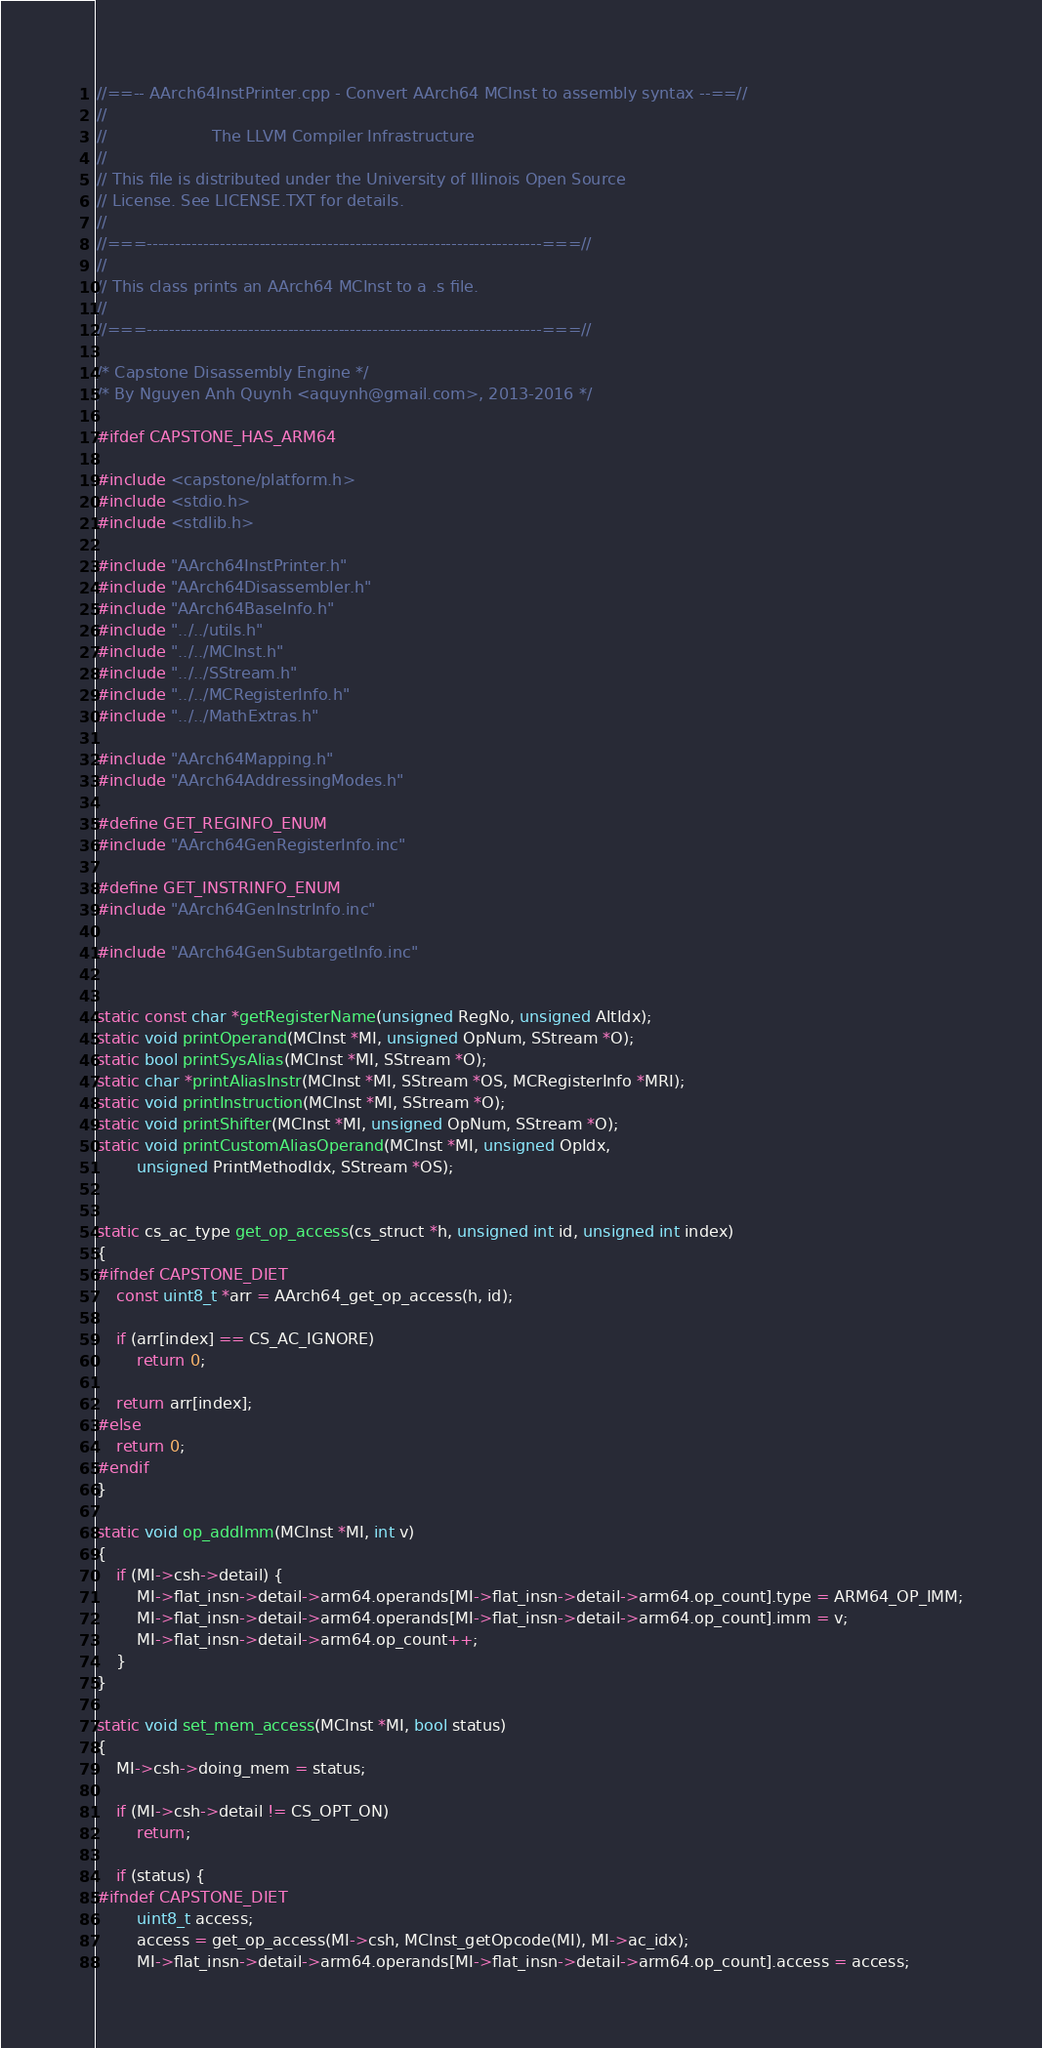Convert code to text. <code><loc_0><loc_0><loc_500><loc_500><_C_>//==-- AArch64InstPrinter.cpp - Convert AArch64 MCInst to assembly syntax --==//
//
//                     The LLVM Compiler Infrastructure
//
// This file is distributed under the University of Illinois Open Source
// License. See LICENSE.TXT for details.
//
//===----------------------------------------------------------------------===//
//
// This class prints an AArch64 MCInst to a .s file.
//
//===----------------------------------------------------------------------===//

/* Capstone Disassembly Engine */
/* By Nguyen Anh Quynh <aquynh@gmail.com>, 2013-2016 */

#ifdef CAPSTONE_HAS_ARM64

#include <capstone/platform.h>
#include <stdio.h>
#include <stdlib.h>

#include "AArch64InstPrinter.h"
#include "AArch64Disassembler.h"
#include "AArch64BaseInfo.h"
#include "../../utils.h"
#include "../../MCInst.h"
#include "../../SStream.h"
#include "../../MCRegisterInfo.h"
#include "../../MathExtras.h"

#include "AArch64Mapping.h"
#include "AArch64AddressingModes.h"

#define GET_REGINFO_ENUM
#include "AArch64GenRegisterInfo.inc"

#define GET_INSTRINFO_ENUM
#include "AArch64GenInstrInfo.inc"

#include "AArch64GenSubtargetInfo.inc"


static const char *getRegisterName(unsigned RegNo, unsigned AltIdx);
static void printOperand(MCInst *MI, unsigned OpNum, SStream *O);
static bool printSysAlias(MCInst *MI, SStream *O);
static char *printAliasInstr(MCInst *MI, SStream *OS, MCRegisterInfo *MRI);
static void printInstruction(MCInst *MI, SStream *O);
static void printShifter(MCInst *MI, unsigned OpNum, SStream *O);
static void printCustomAliasOperand(MCInst *MI, unsigned OpIdx,
		unsigned PrintMethodIdx, SStream *OS);


static cs_ac_type get_op_access(cs_struct *h, unsigned int id, unsigned int index)
{
#ifndef CAPSTONE_DIET
	const uint8_t *arr = AArch64_get_op_access(h, id);

	if (arr[index] == CS_AC_IGNORE)
		return 0;

	return arr[index];
#else
	return 0;
#endif
}

static void op_addImm(MCInst *MI, int v)
{
	if (MI->csh->detail) {
		MI->flat_insn->detail->arm64.operands[MI->flat_insn->detail->arm64.op_count].type = ARM64_OP_IMM;
		MI->flat_insn->detail->arm64.operands[MI->flat_insn->detail->arm64.op_count].imm = v;
		MI->flat_insn->detail->arm64.op_count++;
	}
}

static void set_mem_access(MCInst *MI, bool status)
{
	MI->csh->doing_mem = status;

	if (MI->csh->detail != CS_OPT_ON)
		return;

	if (status) {
#ifndef CAPSTONE_DIET
		uint8_t access;
		access = get_op_access(MI->csh, MCInst_getOpcode(MI), MI->ac_idx);
		MI->flat_insn->detail->arm64.operands[MI->flat_insn->detail->arm64.op_count].access = access;</code> 